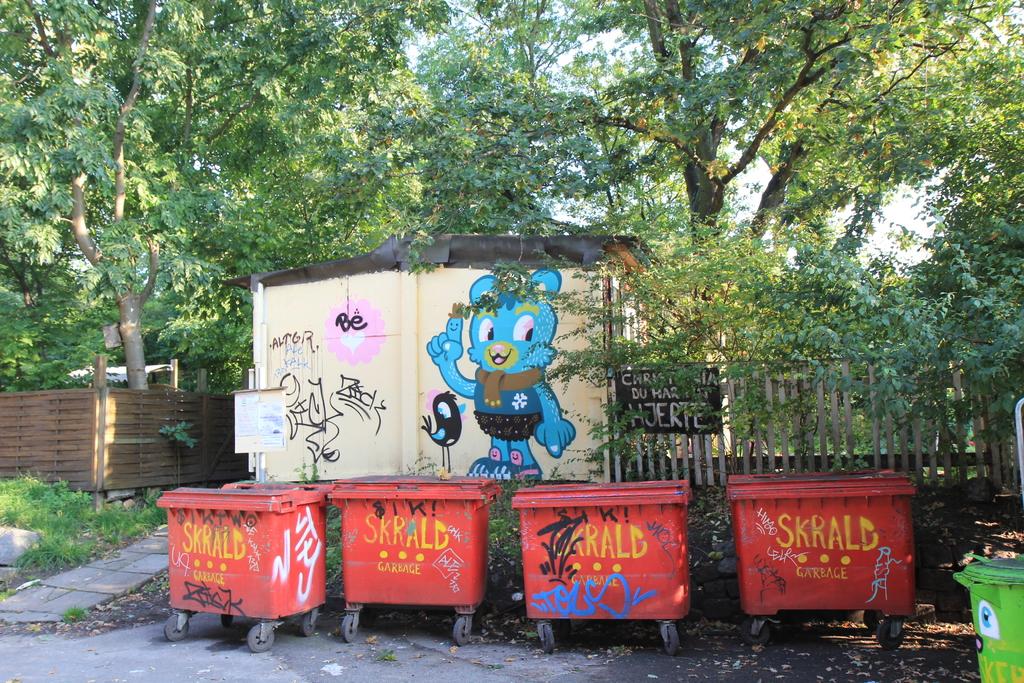What is the name of the garbage company?
Ensure brevity in your answer.  Skrald. 